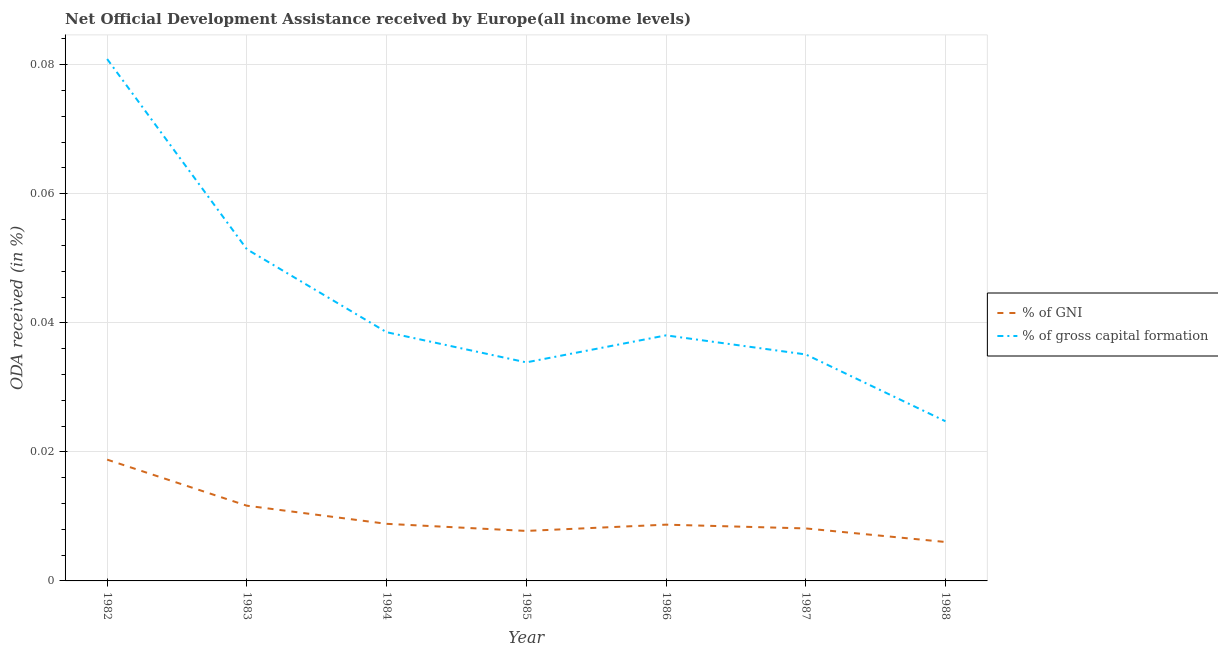Does the line corresponding to oda received as percentage of gni intersect with the line corresponding to oda received as percentage of gross capital formation?
Offer a very short reply. No. What is the oda received as percentage of gross capital formation in 1982?
Provide a succinct answer. 0.08. Across all years, what is the maximum oda received as percentage of gni?
Your response must be concise. 0.02. Across all years, what is the minimum oda received as percentage of gni?
Ensure brevity in your answer.  0.01. In which year was the oda received as percentage of gross capital formation minimum?
Provide a succinct answer. 1988. What is the total oda received as percentage of gni in the graph?
Make the answer very short. 0.07. What is the difference between the oda received as percentage of gni in 1982 and that in 1986?
Your answer should be very brief. 0.01. What is the difference between the oda received as percentage of gni in 1982 and the oda received as percentage of gross capital formation in 1985?
Keep it short and to the point. -0.02. What is the average oda received as percentage of gni per year?
Provide a succinct answer. 0.01. In the year 1983, what is the difference between the oda received as percentage of gni and oda received as percentage of gross capital formation?
Make the answer very short. -0.04. What is the ratio of the oda received as percentage of gni in 1984 to that in 1986?
Keep it short and to the point. 1.01. Is the difference between the oda received as percentage of gni in 1983 and 1985 greater than the difference between the oda received as percentage of gross capital formation in 1983 and 1985?
Your response must be concise. No. What is the difference between the highest and the second highest oda received as percentage of gni?
Provide a short and direct response. 0.01. What is the difference between the highest and the lowest oda received as percentage of gross capital formation?
Offer a terse response. 0.06. Does the oda received as percentage of gross capital formation monotonically increase over the years?
Ensure brevity in your answer.  No. Is the oda received as percentage of gross capital formation strictly greater than the oda received as percentage of gni over the years?
Provide a short and direct response. Yes. How many lines are there?
Keep it short and to the point. 2. Does the graph contain any zero values?
Your response must be concise. No. Does the graph contain grids?
Your response must be concise. Yes. Where does the legend appear in the graph?
Your response must be concise. Center right. What is the title of the graph?
Your answer should be very brief. Net Official Development Assistance received by Europe(all income levels). What is the label or title of the X-axis?
Your answer should be very brief. Year. What is the label or title of the Y-axis?
Provide a succinct answer. ODA received (in %). What is the ODA received (in %) in % of GNI in 1982?
Your response must be concise. 0.02. What is the ODA received (in %) of % of gross capital formation in 1982?
Make the answer very short. 0.08. What is the ODA received (in %) in % of GNI in 1983?
Keep it short and to the point. 0.01. What is the ODA received (in %) in % of gross capital formation in 1983?
Provide a succinct answer. 0.05. What is the ODA received (in %) in % of GNI in 1984?
Your answer should be very brief. 0.01. What is the ODA received (in %) of % of gross capital formation in 1984?
Offer a terse response. 0.04. What is the ODA received (in %) of % of GNI in 1985?
Keep it short and to the point. 0.01. What is the ODA received (in %) of % of gross capital formation in 1985?
Provide a succinct answer. 0.03. What is the ODA received (in %) in % of GNI in 1986?
Provide a succinct answer. 0.01. What is the ODA received (in %) of % of gross capital formation in 1986?
Provide a short and direct response. 0.04. What is the ODA received (in %) of % of GNI in 1987?
Keep it short and to the point. 0.01. What is the ODA received (in %) in % of gross capital formation in 1987?
Ensure brevity in your answer.  0.04. What is the ODA received (in %) in % of GNI in 1988?
Your response must be concise. 0.01. What is the ODA received (in %) of % of gross capital formation in 1988?
Ensure brevity in your answer.  0.02. Across all years, what is the maximum ODA received (in %) in % of GNI?
Your response must be concise. 0.02. Across all years, what is the maximum ODA received (in %) in % of gross capital formation?
Your answer should be very brief. 0.08. Across all years, what is the minimum ODA received (in %) of % of GNI?
Your response must be concise. 0.01. Across all years, what is the minimum ODA received (in %) of % of gross capital formation?
Give a very brief answer. 0.02. What is the total ODA received (in %) of % of GNI in the graph?
Your answer should be very brief. 0.07. What is the total ODA received (in %) in % of gross capital formation in the graph?
Provide a succinct answer. 0.3. What is the difference between the ODA received (in %) in % of GNI in 1982 and that in 1983?
Give a very brief answer. 0.01. What is the difference between the ODA received (in %) in % of gross capital formation in 1982 and that in 1983?
Give a very brief answer. 0.03. What is the difference between the ODA received (in %) of % of GNI in 1982 and that in 1984?
Offer a terse response. 0.01. What is the difference between the ODA received (in %) of % of gross capital formation in 1982 and that in 1984?
Your answer should be compact. 0.04. What is the difference between the ODA received (in %) of % of GNI in 1982 and that in 1985?
Provide a succinct answer. 0.01. What is the difference between the ODA received (in %) in % of gross capital formation in 1982 and that in 1985?
Your answer should be very brief. 0.05. What is the difference between the ODA received (in %) in % of GNI in 1982 and that in 1986?
Your answer should be compact. 0.01. What is the difference between the ODA received (in %) of % of gross capital formation in 1982 and that in 1986?
Provide a short and direct response. 0.04. What is the difference between the ODA received (in %) of % of GNI in 1982 and that in 1987?
Keep it short and to the point. 0.01. What is the difference between the ODA received (in %) of % of gross capital formation in 1982 and that in 1987?
Your answer should be compact. 0.05. What is the difference between the ODA received (in %) in % of GNI in 1982 and that in 1988?
Give a very brief answer. 0.01. What is the difference between the ODA received (in %) of % of gross capital formation in 1982 and that in 1988?
Make the answer very short. 0.06. What is the difference between the ODA received (in %) in % of GNI in 1983 and that in 1984?
Provide a succinct answer. 0. What is the difference between the ODA received (in %) in % of gross capital formation in 1983 and that in 1984?
Give a very brief answer. 0.01. What is the difference between the ODA received (in %) in % of GNI in 1983 and that in 1985?
Your response must be concise. 0. What is the difference between the ODA received (in %) in % of gross capital formation in 1983 and that in 1985?
Ensure brevity in your answer.  0.02. What is the difference between the ODA received (in %) in % of GNI in 1983 and that in 1986?
Your answer should be very brief. 0. What is the difference between the ODA received (in %) of % of gross capital formation in 1983 and that in 1986?
Your answer should be very brief. 0.01. What is the difference between the ODA received (in %) of % of GNI in 1983 and that in 1987?
Make the answer very short. 0. What is the difference between the ODA received (in %) in % of gross capital formation in 1983 and that in 1987?
Ensure brevity in your answer.  0.02. What is the difference between the ODA received (in %) in % of GNI in 1983 and that in 1988?
Provide a succinct answer. 0.01. What is the difference between the ODA received (in %) of % of gross capital formation in 1983 and that in 1988?
Give a very brief answer. 0.03. What is the difference between the ODA received (in %) of % of GNI in 1984 and that in 1985?
Make the answer very short. 0. What is the difference between the ODA received (in %) in % of gross capital formation in 1984 and that in 1985?
Keep it short and to the point. 0. What is the difference between the ODA received (in %) of % of gross capital formation in 1984 and that in 1986?
Your answer should be very brief. 0. What is the difference between the ODA received (in %) of % of GNI in 1984 and that in 1987?
Offer a very short reply. 0. What is the difference between the ODA received (in %) in % of gross capital formation in 1984 and that in 1987?
Give a very brief answer. 0. What is the difference between the ODA received (in %) in % of GNI in 1984 and that in 1988?
Keep it short and to the point. 0. What is the difference between the ODA received (in %) of % of gross capital formation in 1984 and that in 1988?
Your answer should be very brief. 0.01. What is the difference between the ODA received (in %) in % of GNI in 1985 and that in 1986?
Make the answer very short. -0. What is the difference between the ODA received (in %) in % of gross capital formation in 1985 and that in 1986?
Give a very brief answer. -0. What is the difference between the ODA received (in %) in % of GNI in 1985 and that in 1987?
Provide a short and direct response. -0. What is the difference between the ODA received (in %) in % of gross capital formation in 1985 and that in 1987?
Offer a terse response. -0. What is the difference between the ODA received (in %) in % of GNI in 1985 and that in 1988?
Offer a terse response. 0. What is the difference between the ODA received (in %) of % of gross capital formation in 1985 and that in 1988?
Keep it short and to the point. 0.01. What is the difference between the ODA received (in %) in % of GNI in 1986 and that in 1987?
Offer a terse response. 0. What is the difference between the ODA received (in %) in % of gross capital formation in 1986 and that in 1987?
Make the answer very short. 0. What is the difference between the ODA received (in %) of % of GNI in 1986 and that in 1988?
Give a very brief answer. 0. What is the difference between the ODA received (in %) in % of gross capital formation in 1986 and that in 1988?
Offer a very short reply. 0.01. What is the difference between the ODA received (in %) in % of GNI in 1987 and that in 1988?
Your answer should be compact. 0. What is the difference between the ODA received (in %) of % of gross capital formation in 1987 and that in 1988?
Provide a succinct answer. 0.01. What is the difference between the ODA received (in %) of % of GNI in 1982 and the ODA received (in %) of % of gross capital formation in 1983?
Your answer should be compact. -0.03. What is the difference between the ODA received (in %) in % of GNI in 1982 and the ODA received (in %) in % of gross capital formation in 1984?
Keep it short and to the point. -0.02. What is the difference between the ODA received (in %) in % of GNI in 1982 and the ODA received (in %) in % of gross capital formation in 1985?
Provide a short and direct response. -0.02. What is the difference between the ODA received (in %) of % of GNI in 1982 and the ODA received (in %) of % of gross capital formation in 1986?
Provide a succinct answer. -0.02. What is the difference between the ODA received (in %) in % of GNI in 1982 and the ODA received (in %) in % of gross capital formation in 1987?
Your answer should be very brief. -0.02. What is the difference between the ODA received (in %) in % of GNI in 1982 and the ODA received (in %) in % of gross capital formation in 1988?
Make the answer very short. -0.01. What is the difference between the ODA received (in %) in % of GNI in 1983 and the ODA received (in %) in % of gross capital formation in 1984?
Provide a succinct answer. -0.03. What is the difference between the ODA received (in %) in % of GNI in 1983 and the ODA received (in %) in % of gross capital formation in 1985?
Provide a short and direct response. -0.02. What is the difference between the ODA received (in %) of % of GNI in 1983 and the ODA received (in %) of % of gross capital formation in 1986?
Offer a terse response. -0.03. What is the difference between the ODA received (in %) in % of GNI in 1983 and the ODA received (in %) in % of gross capital formation in 1987?
Keep it short and to the point. -0.02. What is the difference between the ODA received (in %) of % of GNI in 1983 and the ODA received (in %) of % of gross capital formation in 1988?
Your answer should be very brief. -0.01. What is the difference between the ODA received (in %) in % of GNI in 1984 and the ODA received (in %) in % of gross capital formation in 1985?
Give a very brief answer. -0.03. What is the difference between the ODA received (in %) of % of GNI in 1984 and the ODA received (in %) of % of gross capital formation in 1986?
Keep it short and to the point. -0.03. What is the difference between the ODA received (in %) of % of GNI in 1984 and the ODA received (in %) of % of gross capital formation in 1987?
Keep it short and to the point. -0.03. What is the difference between the ODA received (in %) of % of GNI in 1984 and the ODA received (in %) of % of gross capital formation in 1988?
Your answer should be very brief. -0.02. What is the difference between the ODA received (in %) of % of GNI in 1985 and the ODA received (in %) of % of gross capital formation in 1986?
Provide a short and direct response. -0.03. What is the difference between the ODA received (in %) in % of GNI in 1985 and the ODA received (in %) in % of gross capital formation in 1987?
Offer a terse response. -0.03. What is the difference between the ODA received (in %) in % of GNI in 1985 and the ODA received (in %) in % of gross capital formation in 1988?
Offer a terse response. -0.02. What is the difference between the ODA received (in %) in % of GNI in 1986 and the ODA received (in %) in % of gross capital formation in 1987?
Provide a short and direct response. -0.03. What is the difference between the ODA received (in %) of % of GNI in 1986 and the ODA received (in %) of % of gross capital formation in 1988?
Keep it short and to the point. -0.02. What is the difference between the ODA received (in %) in % of GNI in 1987 and the ODA received (in %) in % of gross capital formation in 1988?
Offer a terse response. -0.02. What is the average ODA received (in %) in % of GNI per year?
Offer a very short reply. 0.01. What is the average ODA received (in %) of % of gross capital formation per year?
Provide a short and direct response. 0.04. In the year 1982, what is the difference between the ODA received (in %) in % of GNI and ODA received (in %) in % of gross capital formation?
Ensure brevity in your answer.  -0.06. In the year 1983, what is the difference between the ODA received (in %) in % of GNI and ODA received (in %) in % of gross capital formation?
Keep it short and to the point. -0.04. In the year 1984, what is the difference between the ODA received (in %) in % of GNI and ODA received (in %) in % of gross capital formation?
Offer a terse response. -0.03. In the year 1985, what is the difference between the ODA received (in %) in % of GNI and ODA received (in %) in % of gross capital formation?
Provide a short and direct response. -0.03. In the year 1986, what is the difference between the ODA received (in %) in % of GNI and ODA received (in %) in % of gross capital formation?
Keep it short and to the point. -0.03. In the year 1987, what is the difference between the ODA received (in %) of % of GNI and ODA received (in %) of % of gross capital formation?
Your response must be concise. -0.03. In the year 1988, what is the difference between the ODA received (in %) in % of GNI and ODA received (in %) in % of gross capital formation?
Make the answer very short. -0.02. What is the ratio of the ODA received (in %) of % of GNI in 1982 to that in 1983?
Ensure brevity in your answer.  1.61. What is the ratio of the ODA received (in %) in % of gross capital formation in 1982 to that in 1983?
Your response must be concise. 1.57. What is the ratio of the ODA received (in %) in % of GNI in 1982 to that in 1984?
Your response must be concise. 2.12. What is the ratio of the ODA received (in %) in % of gross capital formation in 1982 to that in 1984?
Provide a short and direct response. 2.1. What is the ratio of the ODA received (in %) in % of GNI in 1982 to that in 1985?
Provide a short and direct response. 2.43. What is the ratio of the ODA received (in %) in % of gross capital formation in 1982 to that in 1985?
Keep it short and to the point. 2.39. What is the ratio of the ODA received (in %) in % of GNI in 1982 to that in 1986?
Ensure brevity in your answer.  2.16. What is the ratio of the ODA received (in %) in % of gross capital formation in 1982 to that in 1986?
Make the answer very short. 2.13. What is the ratio of the ODA received (in %) in % of GNI in 1982 to that in 1987?
Offer a very short reply. 2.31. What is the ratio of the ODA received (in %) in % of gross capital formation in 1982 to that in 1987?
Ensure brevity in your answer.  2.3. What is the ratio of the ODA received (in %) in % of GNI in 1982 to that in 1988?
Your response must be concise. 3.12. What is the ratio of the ODA received (in %) of % of gross capital formation in 1982 to that in 1988?
Your answer should be compact. 3.27. What is the ratio of the ODA received (in %) of % of GNI in 1983 to that in 1984?
Your answer should be compact. 1.32. What is the ratio of the ODA received (in %) in % of gross capital formation in 1983 to that in 1984?
Ensure brevity in your answer.  1.33. What is the ratio of the ODA received (in %) in % of GNI in 1983 to that in 1985?
Your response must be concise. 1.5. What is the ratio of the ODA received (in %) of % of gross capital formation in 1983 to that in 1985?
Keep it short and to the point. 1.52. What is the ratio of the ODA received (in %) of % of GNI in 1983 to that in 1986?
Offer a very short reply. 1.34. What is the ratio of the ODA received (in %) of % of gross capital formation in 1983 to that in 1986?
Your answer should be compact. 1.35. What is the ratio of the ODA received (in %) in % of GNI in 1983 to that in 1987?
Make the answer very short. 1.43. What is the ratio of the ODA received (in %) in % of gross capital formation in 1983 to that in 1987?
Your answer should be very brief. 1.46. What is the ratio of the ODA received (in %) in % of GNI in 1983 to that in 1988?
Your answer should be compact. 1.93. What is the ratio of the ODA received (in %) of % of gross capital formation in 1983 to that in 1988?
Your answer should be compact. 2.08. What is the ratio of the ODA received (in %) in % of GNI in 1984 to that in 1985?
Provide a succinct answer. 1.14. What is the ratio of the ODA received (in %) in % of gross capital formation in 1984 to that in 1985?
Keep it short and to the point. 1.14. What is the ratio of the ODA received (in %) of % of GNI in 1984 to that in 1986?
Give a very brief answer. 1.01. What is the ratio of the ODA received (in %) in % of gross capital formation in 1984 to that in 1986?
Make the answer very short. 1.01. What is the ratio of the ODA received (in %) in % of GNI in 1984 to that in 1987?
Keep it short and to the point. 1.09. What is the ratio of the ODA received (in %) of % of gross capital formation in 1984 to that in 1987?
Your response must be concise. 1.1. What is the ratio of the ODA received (in %) in % of GNI in 1984 to that in 1988?
Your answer should be compact. 1.47. What is the ratio of the ODA received (in %) of % of gross capital formation in 1984 to that in 1988?
Provide a succinct answer. 1.56. What is the ratio of the ODA received (in %) of % of GNI in 1985 to that in 1986?
Ensure brevity in your answer.  0.89. What is the ratio of the ODA received (in %) of % of gross capital formation in 1985 to that in 1986?
Your response must be concise. 0.89. What is the ratio of the ODA received (in %) in % of GNI in 1985 to that in 1987?
Your response must be concise. 0.95. What is the ratio of the ODA received (in %) in % of GNI in 1985 to that in 1988?
Offer a terse response. 1.28. What is the ratio of the ODA received (in %) in % of gross capital formation in 1985 to that in 1988?
Make the answer very short. 1.37. What is the ratio of the ODA received (in %) in % of GNI in 1986 to that in 1987?
Provide a succinct answer. 1.07. What is the ratio of the ODA received (in %) of % of gross capital formation in 1986 to that in 1987?
Offer a terse response. 1.08. What is the ratio of the ODA received (in %) in % of GNI in 1986 to that in 1988?
Keep it short and to the point. 1.44. What is the ratio of the ODA received (in %) of % of gross capital formation in 1986 to that in 1988?
Provide a short and direct response. 1.54. What is the ratio of the ODA received (in %) of % of GNI in 1987 to that in 1988?
Ensure brevity in your answer.  1.35. What is the ratio of the ODA received (in %) of % of gross capital formation in 1987 to that in 1988?
Make the answer very short. 1.42. What is the difference between the highest and the second highest ODA received (in %) in % of GNI?
Give a very brief answer. 0.01. What is the difference between the highest and the second highest ODA received (in %) of % of gross capital formation?
Make the answer very short. 0.03. What is the difference between the highest and the lowest ODA received (in %) in % of GNI?
Provide a short and direct response. 0.01. What is the difference between the highest and the lowest ODA received (in %) of % of gross capital formation?
Keep it short and to the point. 0.06. 